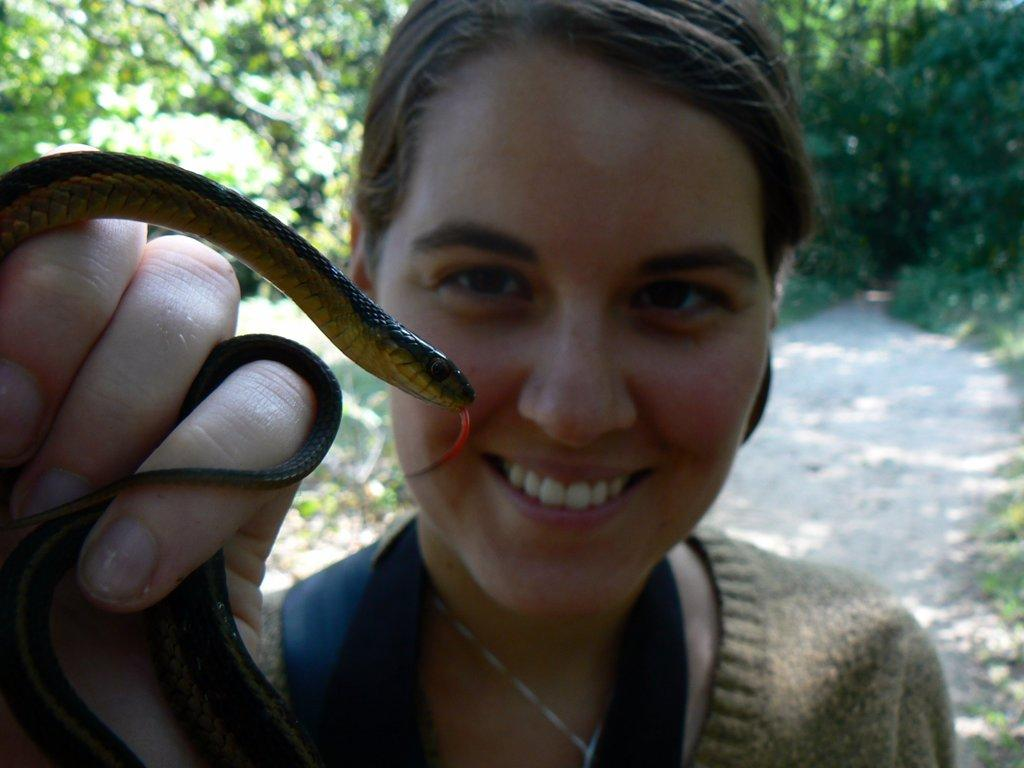Who is present in the image? There is a woman in the image. What is the woman holding in her hand? The woman is holding a snake in her hand. What is the woman's facial expression? The woman is smiling. What can be seen in the background of the image? There are trees in the background of the image. What type of shirt is the woman wearing in the image? The provided facts do not mention the woman's shirt, so we cannot determine the type of shirt she is wearing. --- Facts: 1. There is a car in the image. 2. The car is red. 3. The car has four wheels. 4. There are people in the car. 5. The car is parked on the street. Absurd Topics: umbrella, fish, mountain Conversation: What is the main subject of the image? The main subject of the image is a car. What color is the car? The car is red. How many wheels does the car have? The car has four wheels. Are there any passengers in the car? Yes, there are people in the car. Where is the car located in the image? The car is parked on the street. Reasoning: Let's think step by step in order to produce the conversation. We start by identifying the main subject in the image, which is the car. Then, we describe the car's color and the number of wheels it has. We also mention that there are people in the car and where the car is located, which is on the street. Each question is designed to elicit a specific detail about the image that is known from the provided facts. Absurd Question/Answer: Can you see any fish swimming near the car in the image? No, there are no fish present in the image. 